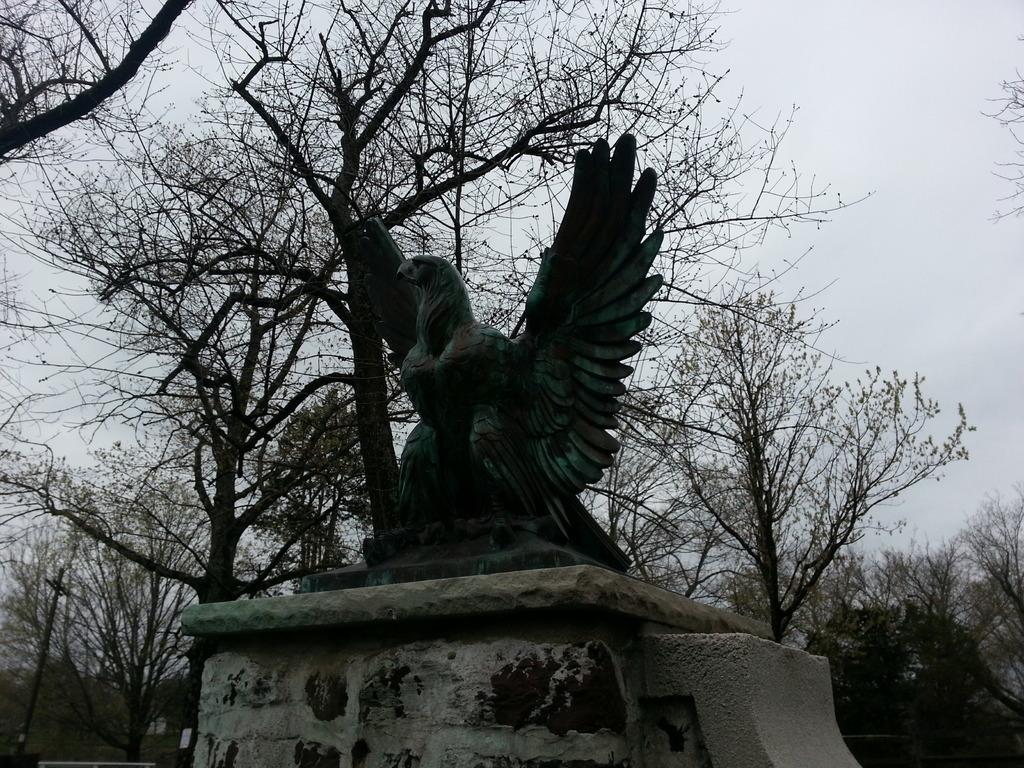What is the main subject of the image? There is a statue of an eagle in the image. What can be seen in the background of the image? There are trees and the sky visible in the background of the image. How many bubbles can be seen floating around the eagle statue in the image? There are no bubbles present in the image; it features a statue of an eagle with trees and the sky in the background. 